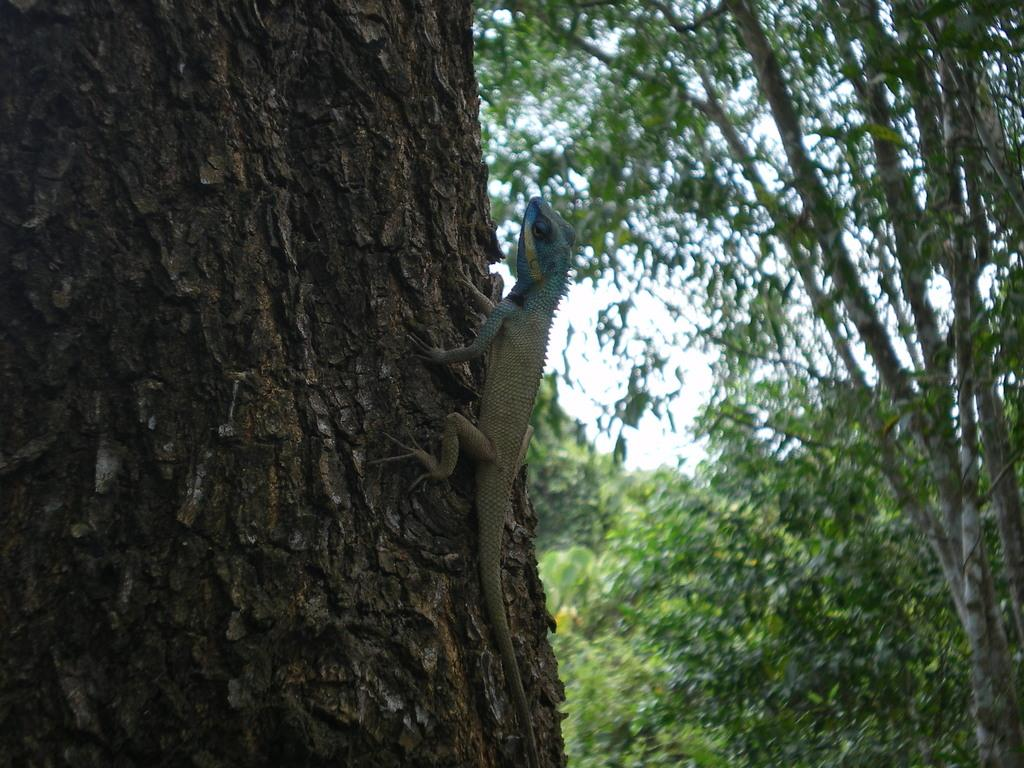What type of animal is on the tree in the image? There is a reptile on a tree in the image. What else can be seen in the background of the image? There are additional trees visible in the background of the image. What type of toys are made of steel and can be seen in the image? There are no toys or steel objects present in the image; it features a reptile on a tree and additional trees in the background. 